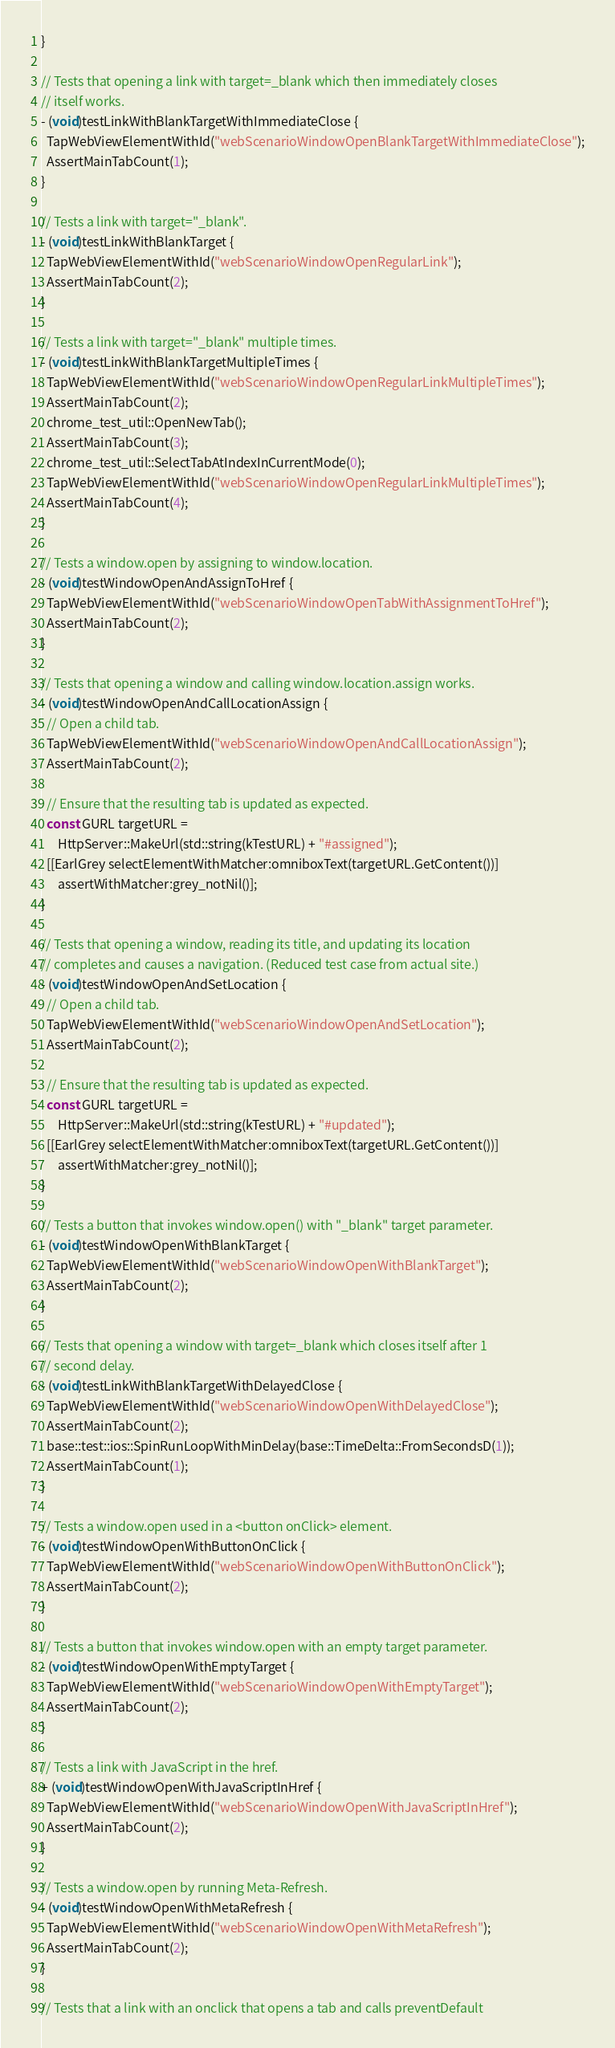<code> <loc_0><loc_0><loc_500><loc_500><_ObjectiveC_>}

// Tests that opening a link with target=_blank which then immediately closes
// itself works.
- (void)testLinkWithBlankTargetWithImmediateClose {
  TapWebViewElementWithId("webScenarioWindowOpenBlankTargetWithImmediateClose");
  AssertMainTabCount(1);
}

// Tests a link with target="_blank".
- (void)testLinkWithBlankTarget {
  TapWebViewElementWithId("webScenarioWindowOpenRegularLink");
  AssertMainTabCount(2);
}

// Tests a link with target="_blank" multiple times.
- (void)testLinkWithBlankTargetMultipleTimes {
  TapWebViewElementWithId("webScenarioWindowOpenRegularLinkMultipleTimes");
  AssertMainTabCount(2);
  chrome_test_util::OpenNewTab();
  AssertMainTabCount(3);
  chrome_test_util::SelectTabAtIndexInCurrentMode(0);
  TapWebViewElementWithId("webScenarioWindowOpenRegularLinkMultipleTimes");
  AssertMainTabCount(4);
}

// Tests a window.open by assigning to window.location.
- (void)testWindowOpenAndAssignToHref {
  TapWebViewElementWithId("webScenarioWindowOpenTabWithAssignmentToHref");
  AssertMainTabCount(2);
}

// Tests that opening a window and calling window.location.assign works.
- (void)testWindowOpenAndCallLocationAssign {
  // Open a child tab.
  TapWebViewElementWithId("webScenarioWindowOpenAndCallLocationAssign");
  AssertMainTabCount(2);

  // Ensure that the resulting tab is updated as expected.
  const GURL targetURL =
      HttpServer::MakeUrl(std::string(kTestURL) + "#assigned");
  [[EarlGrey selectElementWithMatcher:omniboxText(targetURL.GetContent())]
      assertWithMatcher:grey_notNil()];
}

// Tests that opening a window, reading its title, and updating its location
// completes and causes a navigation. (Reduced test case from actual site.)
- (void)testWindowOpenAndSetLocation {
  // Open a child tab.
  TapWebViewElementWithId("webScenarioWindowOpenAndSetLocation");
  AssertMainTabCount(2);

  // Ensure that the resulting tab is updated as expected.
  const GURL targetURL =
      HttpServer::MakeUrl(std::string(kTestURL) + "#updated");
  [[EarlGrey selectElementWithMatcher:omniboxText(targetURL.GetContent())]
      assertWithMatcher:grey_notNil()];
}

// Tests a button that invokes window.open() with "_blank" target parameter.
- (void)testWindowOpenWithBlankTarget {
  TapWebViewElementWithId("webScenarioWindowOpenWithBlankTarget");
  AssertMainTabCount(2);
}

// Tests that opening a window with target=_blank which closes itself after 1
// second delay.
- (void)testLinkWithBlankTargetWithDelayedClose {
  TapWebViewElementWithId("webScenarioWindowOpenWithDelayedClose");
  AssertMainTabCount(2);
  base::test::ios::SpinRunLoopWithMinDelay(base::TimeDelta::FromSecondsD(1));
  AssertMainTabCount(1);
}

// Tests a window.open used in a <button onClick> element.
- (void)testWindowOpenWithButtonOnClick {
  TapWebViewElementWithId("webScenarioWindowOpenWithButtonOnClick");
  AssertMainTabCount(2);
}

// Tests a button that invokes window.open with an empty target parameter.
- (void)testWindowOpenWithEmptyTarget {
  TapWebViewElementWithId("webScenarioWindowOpenWithEmptyTarget");
  AssertMainTabCount(2);
}

// Tests a link with JavaScript in the href.
+ (void)testWindowOpenWithJavaScriptInHref {
  TapWebViewElementWithId("webScenarioWindowOpenWithJavaScriptInHref");
  AssertMainTabCount(2);
}

// Tests a window.open by running Meta-Refresh.
- (void)testWindowOpenWithMetaRefresh {
  TapWebViewElementWithId("webScenarioWindowOpenWithMetaRefresh");
  AssertMainTabCount(2);
}

// Tests that a link with an onclick that opens a tab and calls preventDefault</code> 